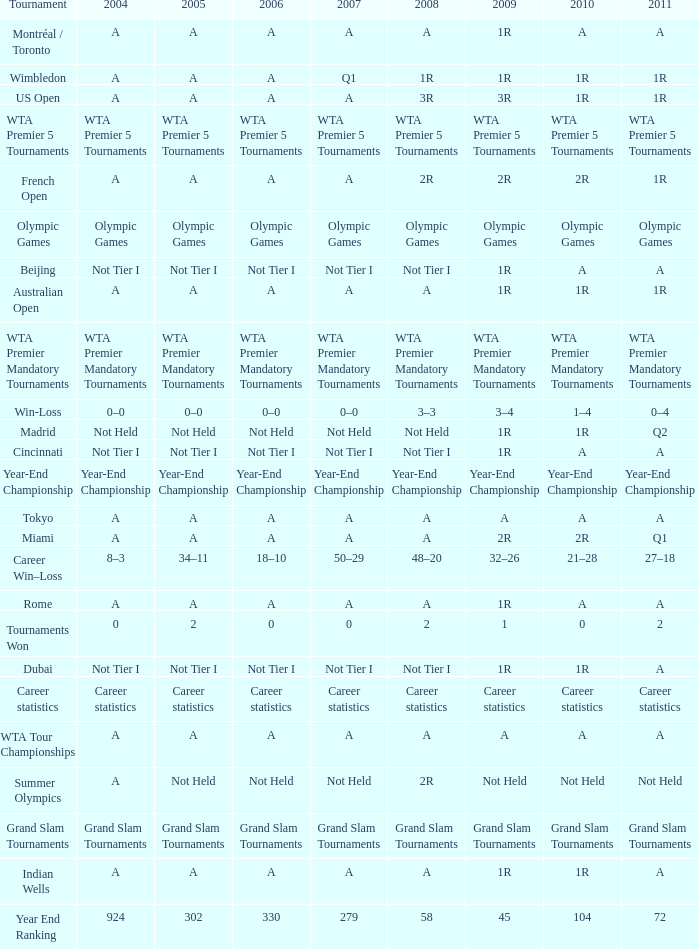What is 2004, when 2005 is "Not Tier I"? Not Tier I, Not Tier I, Not Tier I. 